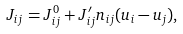Convert formula to latex. <formula><loc_0><loc_0><loc_500><loc_500>J _ { i j } = J _ { i j } ^ { 0 } + J _ { i j } ^ { \prime } { n } _ { i j } ( { u } _ { i } - { u } _ { j } ) ,</formula> 